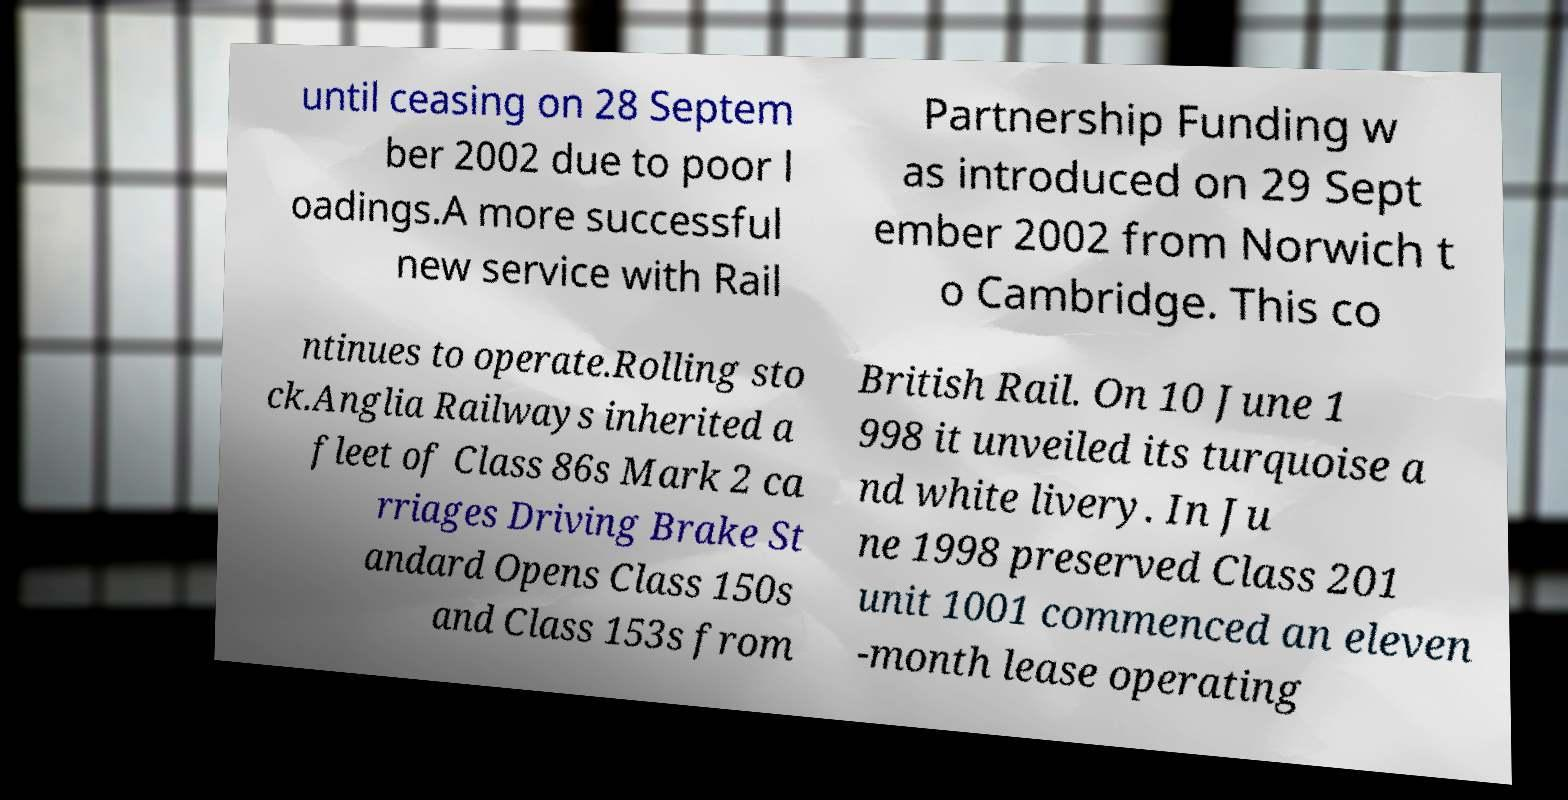Can you read and provide the text displayed in the image?This photo seems to have some interesting text. Can you extract and type it out for me? until ceasing on 28 Septem ber 2002 due to poor l oadings.A more successful new service with Rail Partnership Funding w as introduced on 29 Sept ember 2002 from Norwich t o Cambridge. This co ntinues to operate.Rolling sto ck.Anglia Railways inherited a fleet of Class 86s Mark 2 ca rriages Driving Brake St andard Opens Class 150s and Class 153s from British Rail. On 10 June 1 998 it unveiled its turquoise a nd white livery. In Ju ne 1998 preserved Class 201 unit 1001 commenced an eleven -month lease operating 